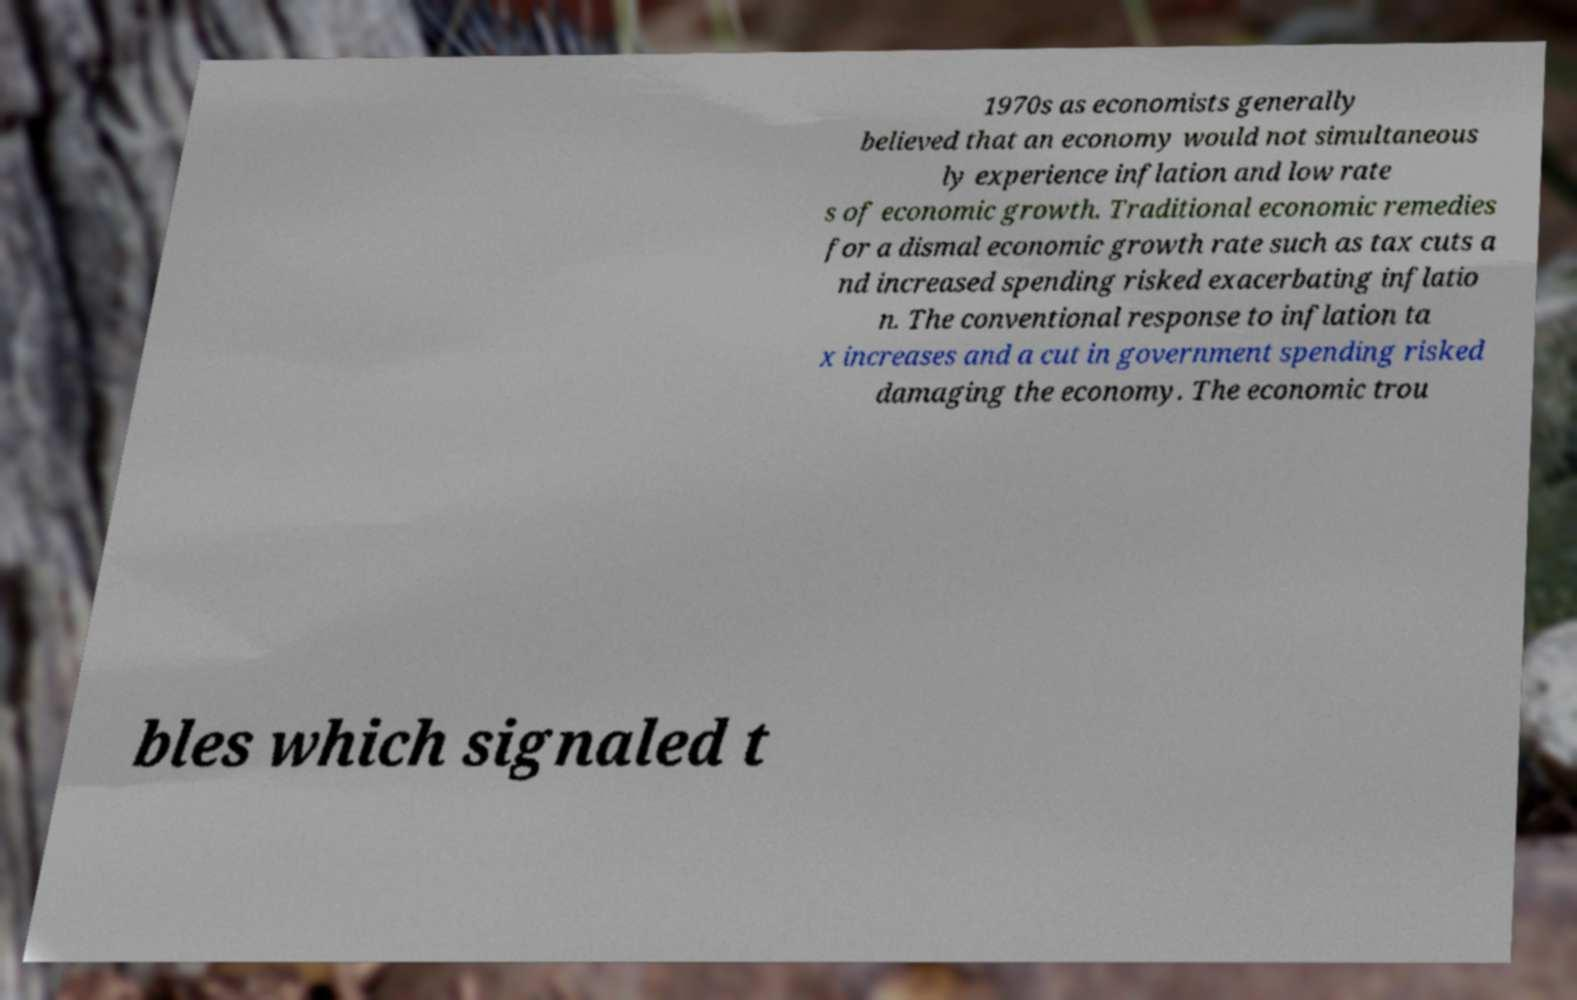Can you read and provide the text displayed in the image?This photo seems to have some interesting text. Can you extract and type it out for me? 1970s as economists generally believed that an economy would not simultaneous ly experience inflation and low rate s of economic growth. Traditional economic remedies for a dismal economic growth rate such as tax cuts a nd increased spending risked exacerbating inflatio n. The conventional response to inflation ta x increases and a cut in government spending risked damaging the economy. The economic trou bles which signaled t 